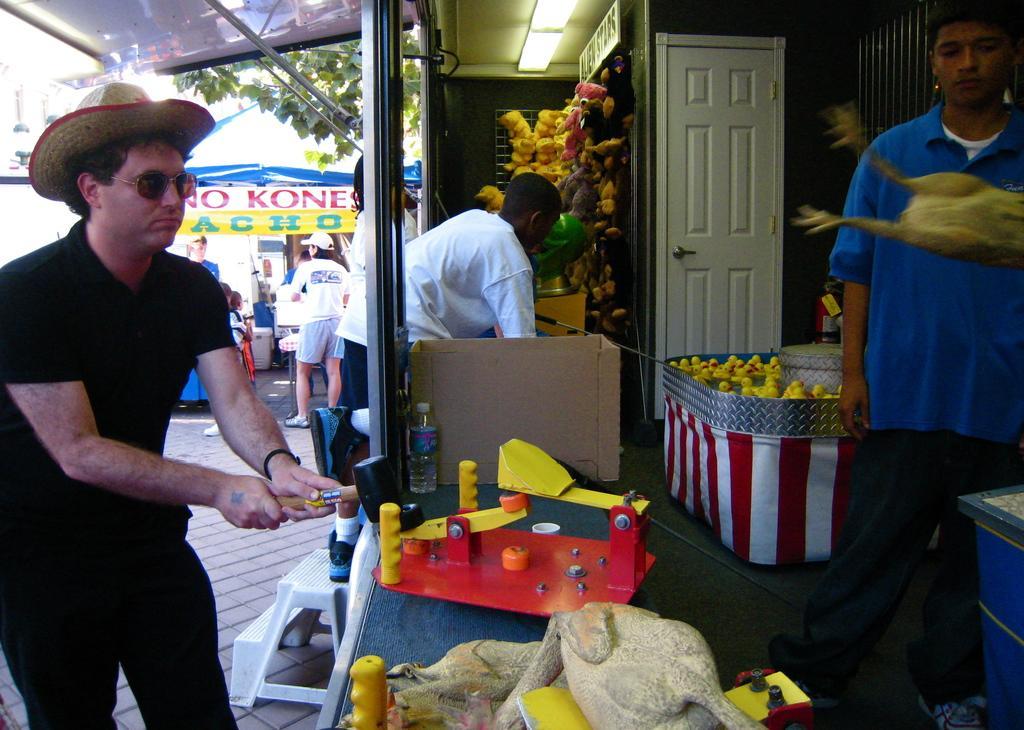Please provide a concise description of this image. In front of the image there are some objects on the platform. There is a closed door. On top of the roof there are lights. There are people standing. In the background of the image there is a tent. Under the tent there are a few objects. There are trees. 